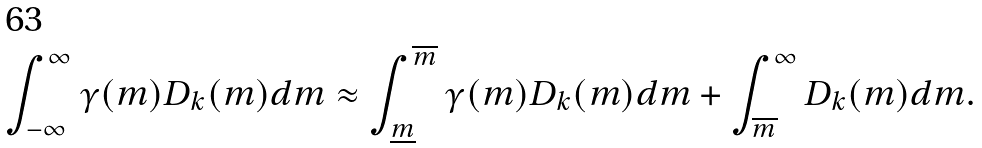<formula> <loc_0><loc_0><loc_500><loc_500>\int _ { - \infty } ^ { \infty } \gamma ( m ) D _ { k } ( m ) d m \approx \int _ { \underline { m } } ^ { \overline { m } } \gamma ( m ) D _ { k } ( m ) d m + \int _ { \overline { m } } ^ { \infty } D _ { k } ( m ) d m .</formula> 